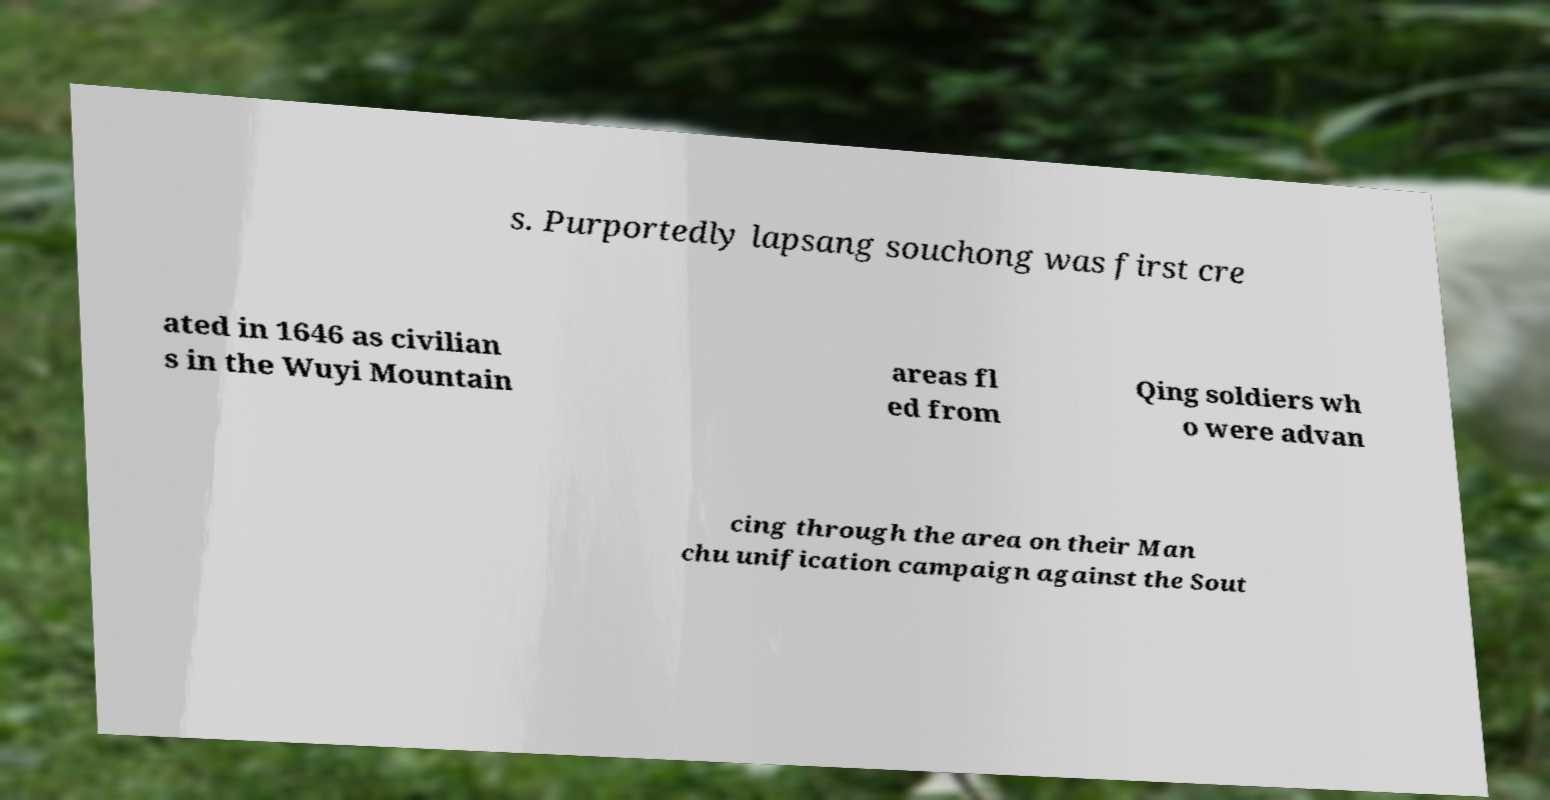I need the written content from this picture converted into text. Can you do that? s. Purportedly lapsang souchong was first cre ated in 1646 as civilian s in the Wuyi Mountain areas fl ed from Qing soldiers wh o were advan cing through the area on their Man chu unification campaign against the Sout 